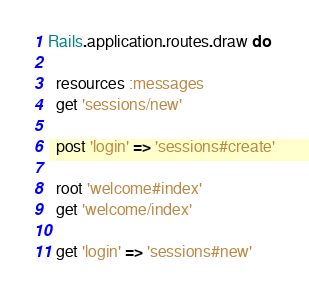Convert code to text. <code><loc_0><loc_0><loc_500><loc_500><_Ruby_>Rails.application.routes.draw do
  
  resources :messages
  get 'sessions/new'

  post 'login' => 'sessions#create'

  root 'welcome#index'
  get 'welcome/index'

  get 'login' => 'sessions#new'</code> 